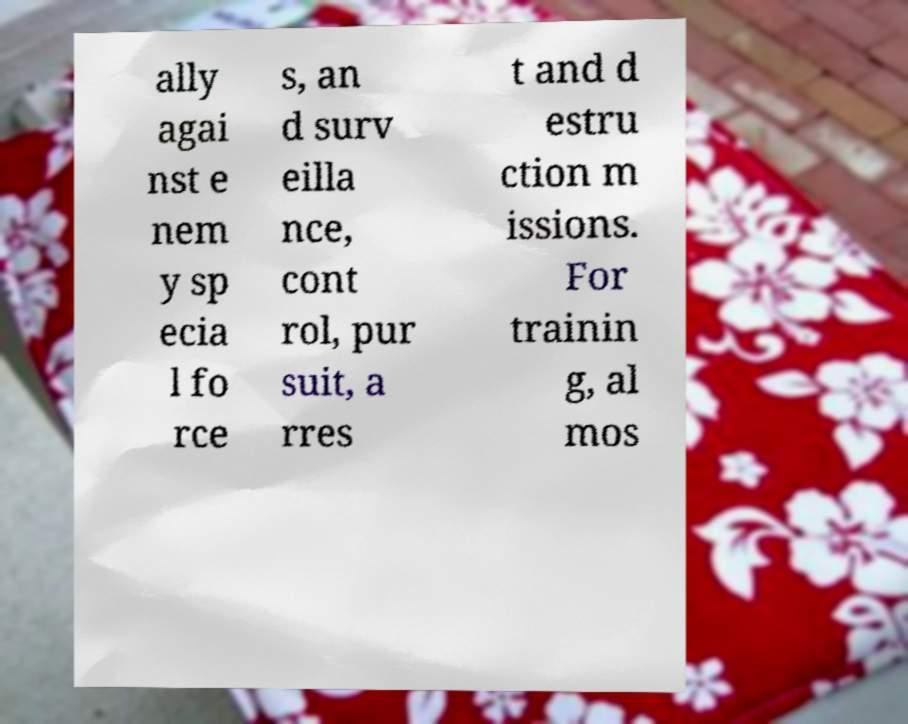Can you read and provide the text displayed in the image?This photo seems to have some interesting text. Can you extract and type it out for me? ally agai nst e nem y sp ecia l fo rce s, an d surv eilla nce, cont rol, pur suit, a rres t and d estru ction m issions. For trainin g, al mos 